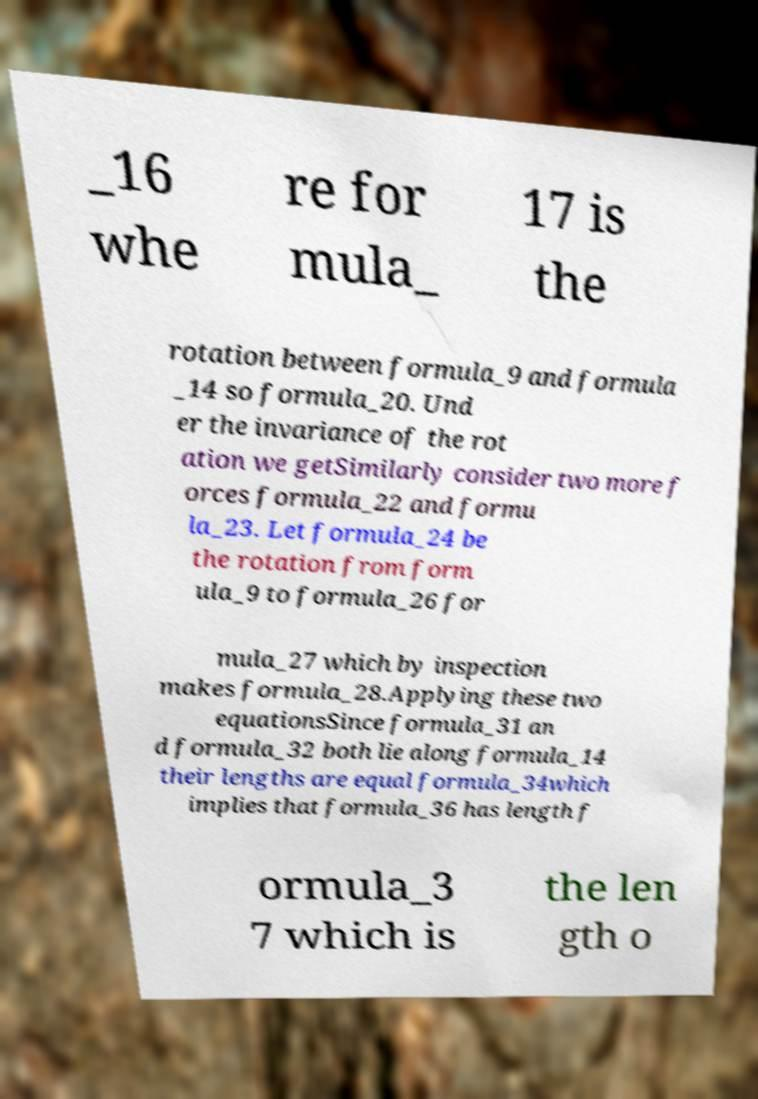I need the written content from this picture converted into text. Can you do that? _16 whe re for mula_ 17 is the rotation between formula_9 and formula _14 so formula_20. Und er the invariance of the rot ation we getSimilarly consider two more f orces formula_22 and formu la_23. Let formula_24 be the rotation from form ula_9 to formula_26 for mula_27 which by inspection makes formula_28.Applying these two equationsSince formula_31 an d formula_32 both lie along formula_14 their lengths are equal formula_34which implies that formula_36 has length f ormula_3 7 which is the len gth o 